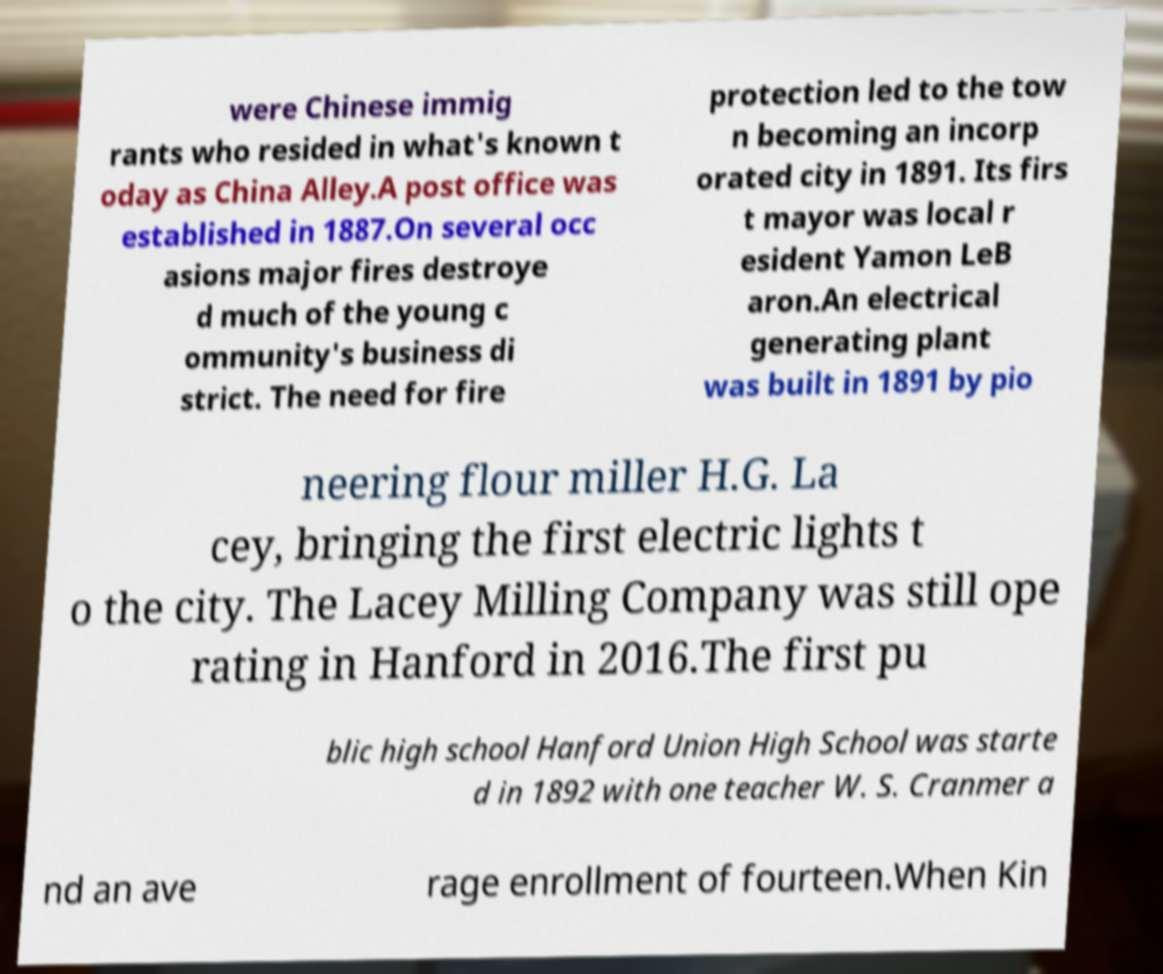What messages or text are displayed in this image? I need them in a readable, typed format. were Chinese immig rants who resided in what's known t oday as China Alley.A post office was established in 1887.On several occ asions major fires destroye d much of the young c ommunity's business di strict. The need for fire protection led to the tow n becoming an incorp orated city in 1891. Its firs t mayor was local r esident Yamon LeB aron.An electrical generating plant was built in 1891 by pio neering flour miller H.G. La cey, bringing the first electric lights t o the city. The Lacey Milling Company was still ope rating in Hanford in 2016.The first pu blic high school Hanford Union High School was starte d in 1892 with one teacher W. S. Cranmer a nd an ave rage enrollment of fourteen.When Kin 